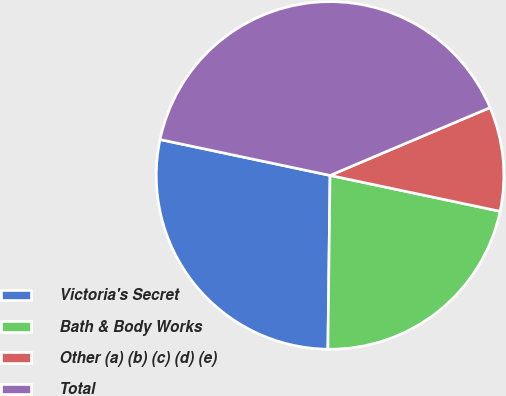<chart> <loc_0><loc_0><loc_500><loc_500><pie_chart><fcel>Victoria's Secret<fcel>Bath & Body Works<fcel>Other (a) (b) (c) (d) (e)<fcel>Total<nl><fcel>28.11%<fcel>21.89%<fcel>9.69%<fcel>40.31%<nl></chart> 